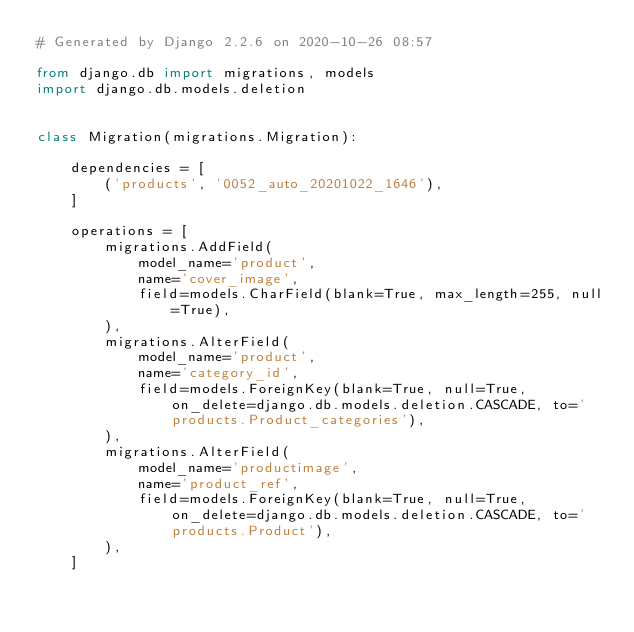Convert code to text. <code><loc_0><loc_0><loc_500><loc_500><_Python_># Generated by Django 2.2.6 on 2020-10-26 08:57

from django.db import migrations, models
import django.db.models.deletion


class Migration(migrations.Migration):

    dependencies = [
        ('products', '0052_auto_20201022_1646'),
    ]

    operations = [
        migrations.AddField(
            model_name='product',
            name='cover_image',
            field=models.CharField(blank=True, max_length=255, null=True),
        ),
        migrations.AlterField(
            model_name='product',
            name='category_id',
            field=models.ForeignKey(blank=True, null=True, on_delete=django.db.models.deletion.CASCADE, to='products.Product_categories'),
        ),
        migrations.AlterField(
            model_name='productimage',
            name='product_ref',
            field=models.ForeignKey(blank=True, null=True, on_delete=django.db.models.deletion.CASCADE, to='products.Product'),
        ),
    ]
</code> 